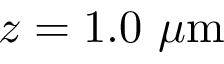<formula> <loc_0><loc_0><loc_500><loc_500>z = 1 . 0 \ \mu m</formula> 